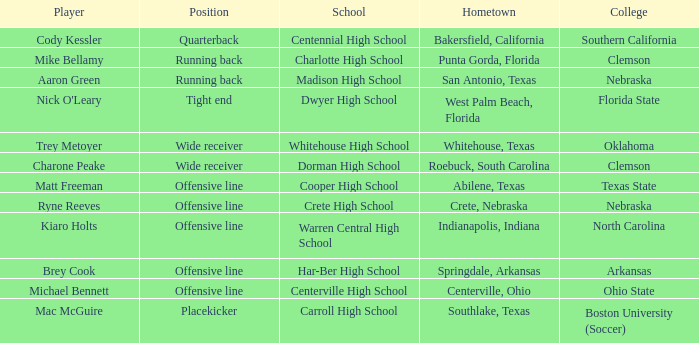What was the position of the player that went to warren central high school? Offensive line. 